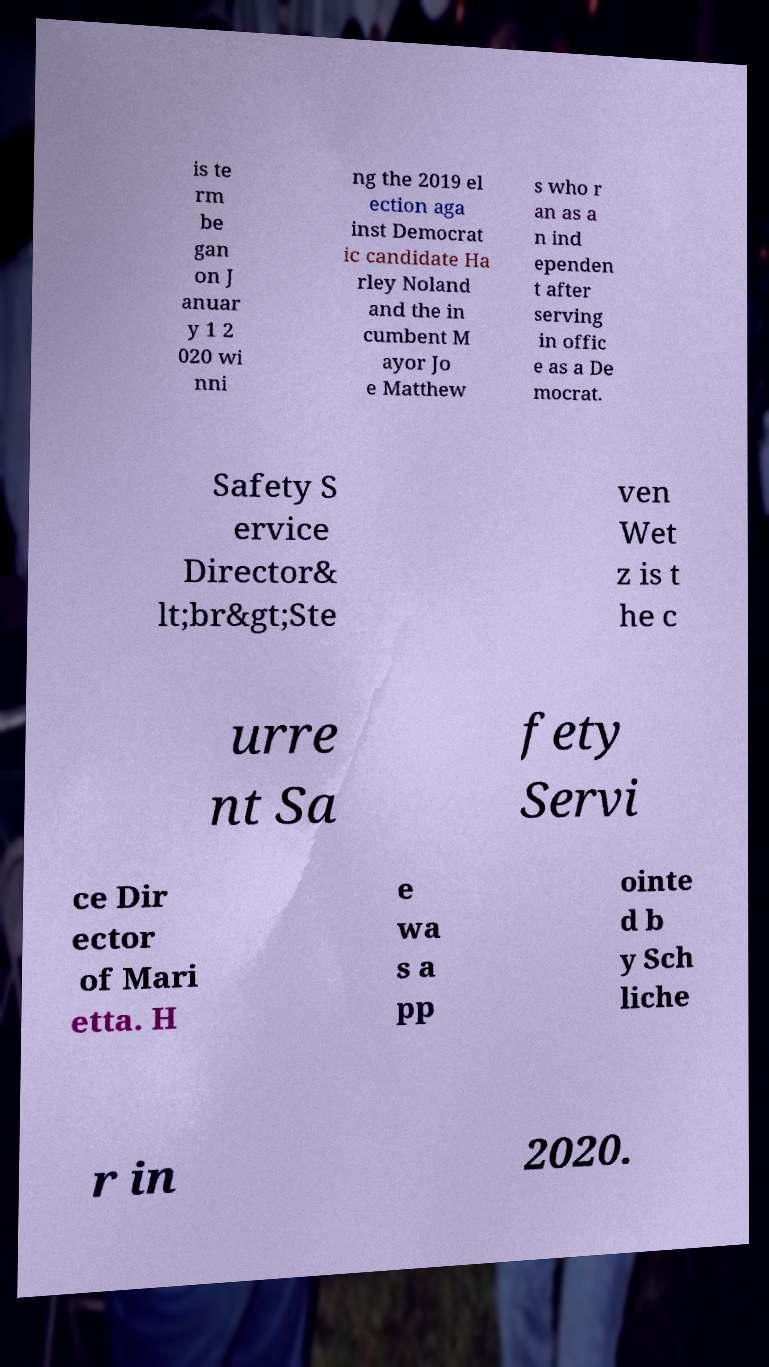Can you read and provide the text displayed in the image?This photo seems to have some interesting text. Can you extract and type it out for me? is te rm be gan on J anuar y 1 2 020 wi nni ng the 2019 el ection aga inst Democrat ic candidate Ha rley Noland and the in cumbent M ayor Jo e Matthew s who r an as a n ind ependen t after serving in offic e as a De mocrat. Safety S ervice Director& lt;br&gt;Ste ven Wet z is t he c urre nt Sa fety Servi ce Dir ector of Mari etta. H e wa s a pp ointe d b y Sch liche r in 2020. 